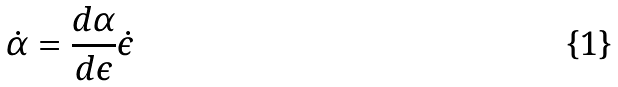<formula> <loc_0><loc_0><loc_500><loc_500>\dot { \alpha } = \frac { d \alpha } { d \epsilon } \dot { \epsilon }</formula> 